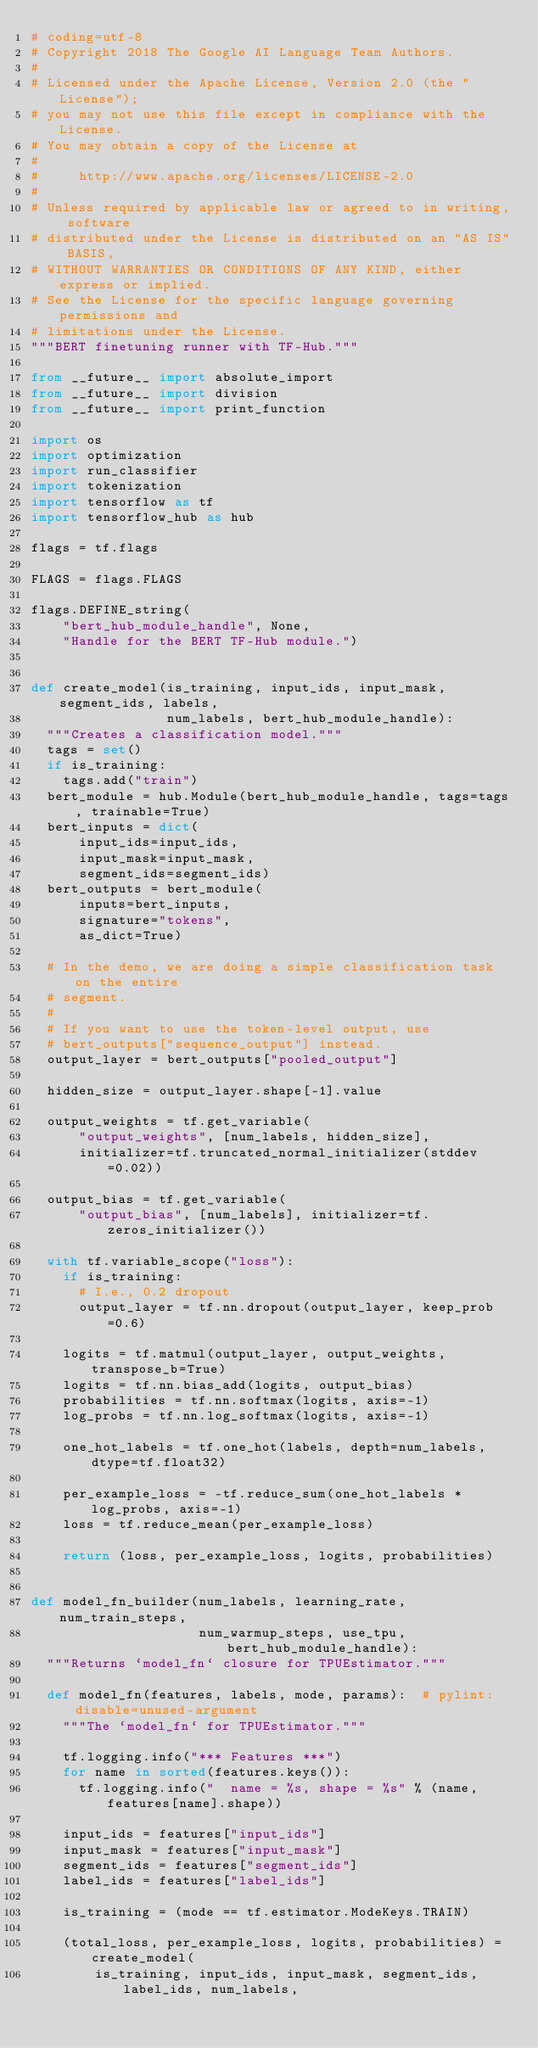Convert code to text. <code><loc_0><loc_0><loc_500><loc_500><_Python_># coding=utf-8
# Copyright 2018 The Google AI Language Team Authors.
#
# Licensed under the Apache License, Version 2.0 (the "License");
# you may not use this file except in compliance with the License.
# You may obtain a copy of the License at
#
#     http://www.apache.org/licenses/LICENSE-2.0
#
# Unless required by applicable law or agreed to in writing, software
# distributed under the License is distributed on an "AS IS" BASIS,
# WITHOUT WARRANTIES OR CONDITIONS OF ANY KIND, either express or implied.
# See the License for the specific language governing permissions and
# limitations under the License.
"""BERT finetuning runner with TF-Hub."""

from __future__ import absolute_import
from __future__ import division
from __future__ import print_function

import os
import optimization
import run_classifier
import tokenization
import tensorflow as tf
import tensorflow_hub as hub

flags = tf.flags

FLAGS = flags.FLAGS

flags.DEFINE_string(
    "bert_hub_module_handle", None,
    "Handle for the BERT TF-Hub module.")


def create_model(is_training, input_ids, input_mask, segment_ids, labels,
                 num_labels, bert_hub_module_handle):
  """Creates a classification model."""
  tags = set()
  if is_training:
    tags.add("train")
  bert_module = hub.Module(bert_hub_module_handle, tags=tags, trainable=True)
  bert_inputs = dict(
      input_ids=input_ids,
      input_mask=input_mask,
      segment_ids=segment_ids)
  bert_outputs = bert_module(
      inputs=bert_inputs,
      signature="tokens",
      as_dict=True)

  # In the demo, we are doing a simple classification task on the entire
  # segment.
  #
  # If you want to use the token-level output, use
  # bert_outputs["sequence_output"] instead.
  output_layer = bert_outputs["pooled_output"]

  hidden_size = output_layer.shape[-1].value

  output_weights = tf.get_variable(
      "output_weights", [num_labels, hidden_size],
      initializer=tf.truncated_normal_initializer(stddev=0.02))

  output_bias = tf.get_variable(
      "output_bias", [num_labels], initializer=tf.zeros_initializer())

  with tf.variable_scope("loss"):
    if is_training:
      # I.e., 0.2 dropout
      output_layer = tf.nn.dropout(output_layer, keep_prob=0.6)

    logits = tf.matmul(output_layer, output_weights, transpose_b=True)
    logits = tf.nn.bias_add(logits, output_bias)
    probabilities = tf.nn.softmax(logits, axis=-1)
    log_probs = tf.nn.log_softmax(logits, axis=-1)

    one_hot_labels = tf.one_hot(labels, depth=num_labels, dtype=tf.float32)

    per_example_loss = -tf.reduce_sum(one_hot_labels * log_probs, axis=-1)
    loss = tf.reduce_mean(per_example_loss)

    return (loss, per_example_loss, logits, probabilities)


def model_fn_builder(num_labels, learning_rate, num_train_steps,
                     num_warmup_steps, use_tpu, bert_hub_module_handle):
  """Returns `model_fn` closure for TPUEstimator."""

  def model_fn(features, labels, mode, params):  # pylint: disable=unused-argument
    """The `model_fn` for TPUEstimator."""

    tf.logging.info("*** Features ***")
    for name in sorted(features.keys()):
      tf.logging.info("  name = %s, shape = %s" % (name, features[name].shape))

    input_ids = features["input_ids"]
    input_mask = features["input_mask"]
    segment_ids = features["segment_ids"]
    label_ids = features["label_ids"]

    is_training = (mode == tf.estimator.ModeKeys.TRAIN)

    (total_loss, per_example_loss, logits, probabilities) = create_model(
        is_training, input_ids, input_mask, segment_ids, label_ids, num_labels,</code> 